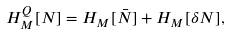<formula> <loc_0><loc_0><loc_500><loc_500>H ^ { Q } _ { M } [ N ] = H _ { M } [ \bar { N } ] + H _ { M } [ \delta N ] ,</formula> 